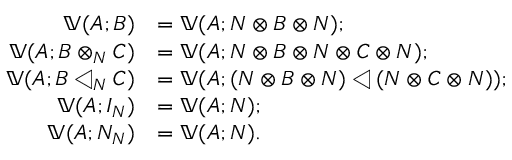Convert formula to latex. <formula><loc_0><loc_0><loc_500><loc_500>\begin{array} { r l } { ( A ; B ) } & { = ( A ; N B N ) ; } \\ { ( A ; B _ { N } C ) } & { = ( A ; N B N C N ) ; } \\ { ( A ; B _ { N } C ) } & { = ( A ; ( N B N ) ( N C N ) ) ; } \\ { ( A ; I _ { N } ) } & { = ( A ; N ) ; } \\ { ( A ; N _ { N } ) } & { = ( A ; N ) . } \end{array}</formula> 